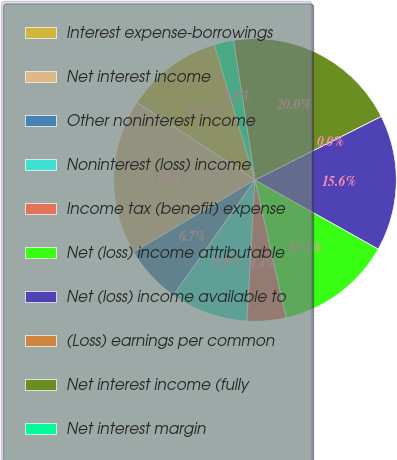Convert chart to OTSL. <chart><loc_0><loc_0><loc_500><loc_500><pie_chart><fcel>Interest expense-borrowings<fcel>Net interest income<fcel>Other noninterest income<fcel>Noninterest (loss) income<fcel>Income tax (benefit) expense<fcel>Net (loss) income attributable<fcel>Net (loss) income available to<fcel>(Loss) earnings per common<fcel>Net interest income (fully<fcel>Net interest margin<nl><fcel>11.11%<fcel>17.78%<fcel>6.67%<fcel>8.89%<fcel>4.44%<fcel>13.33%<fcel>15.56%<fcel>0.0%<fcel>20.0%<fcel>2.22%<nl></chart> 